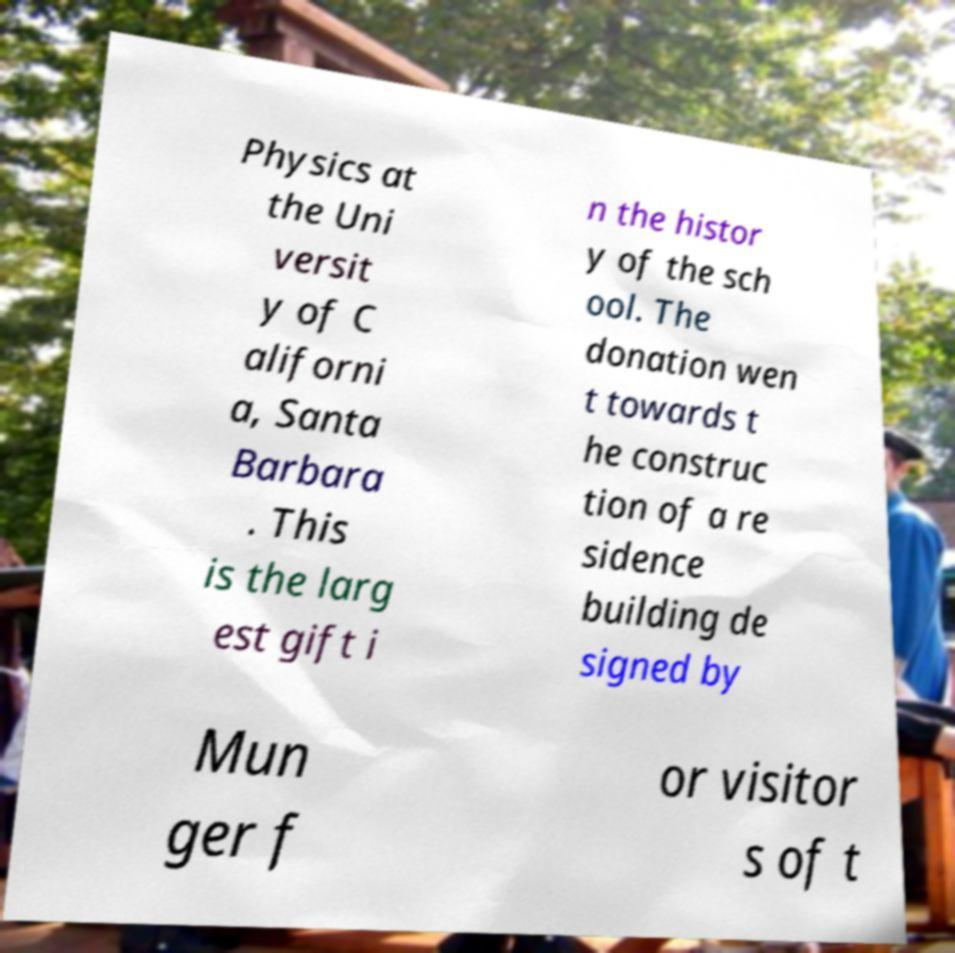Can you read and provide the text displayed in the image?This photo seems to have some interesting text. Can you extract and type it out for me? Physics at the Uni versit y of C aliforni a, Santa Barbara . This is the larg est gift i n the histor y of the sch ool. The donation wen t towards t he construc tion of a re sidence building de signed by Mun ger f or visitor s of t 